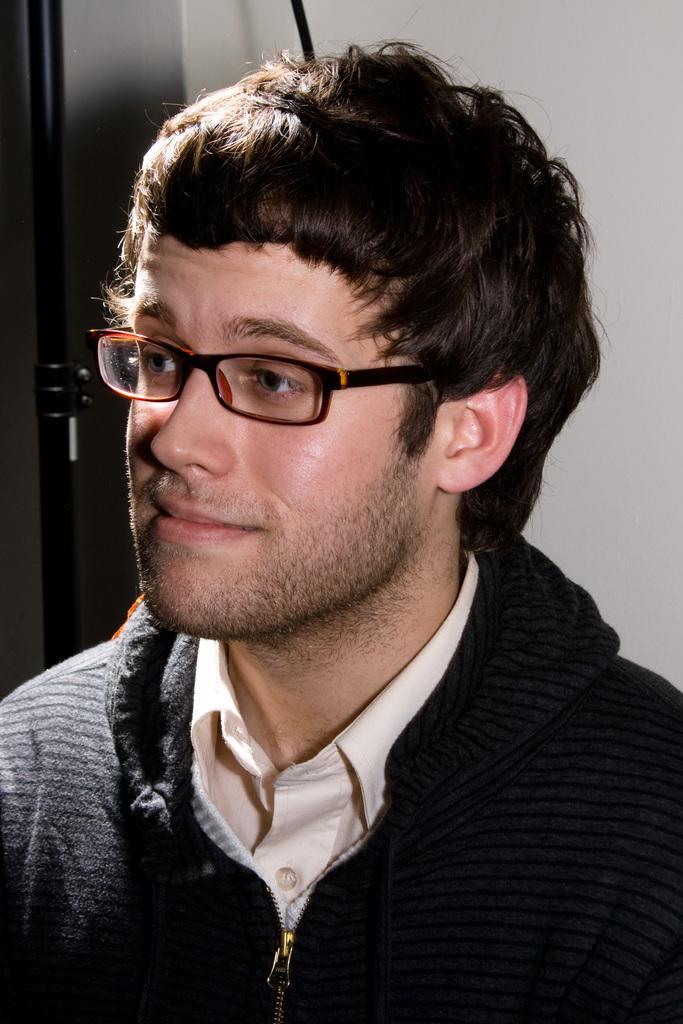Please provide a concise description of this image. In this picture there is a man who wear a black jacket and he has spectacles. And on the background there is a wall. 